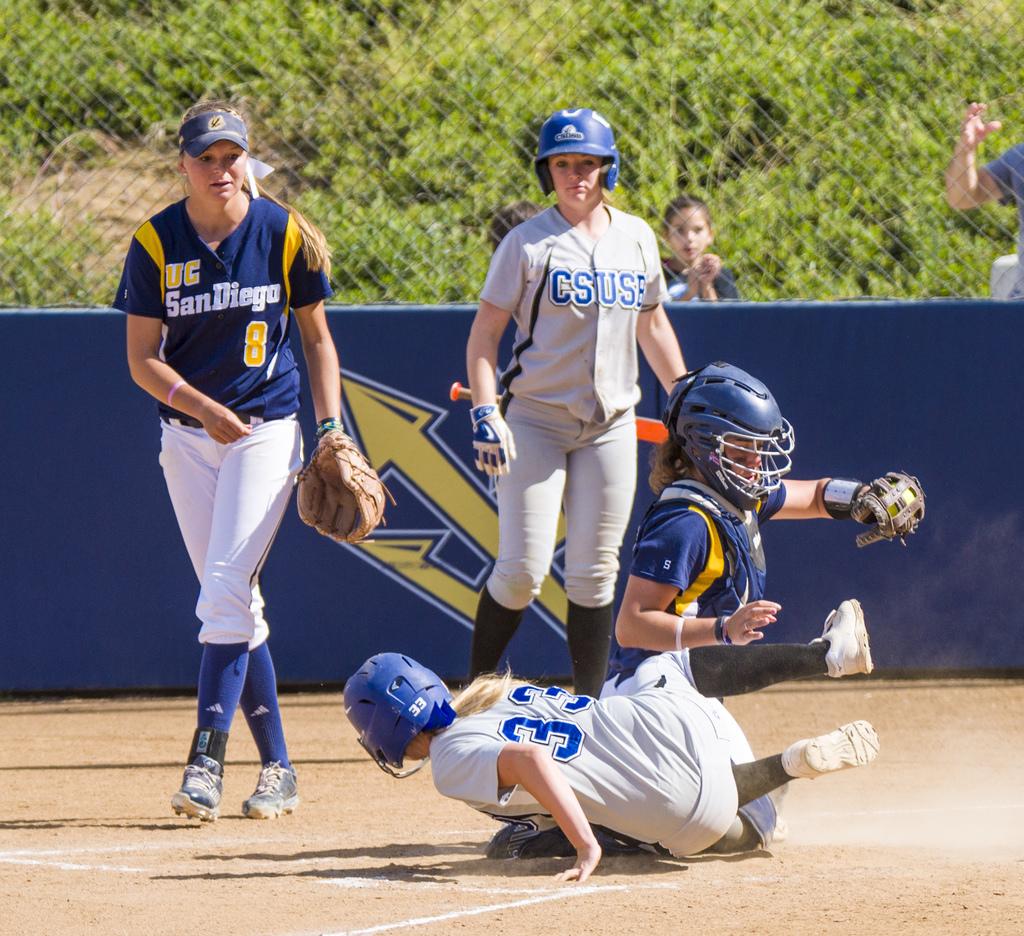What number is the jersey of the girl on the floor?
Give a very brief answer. 33. 